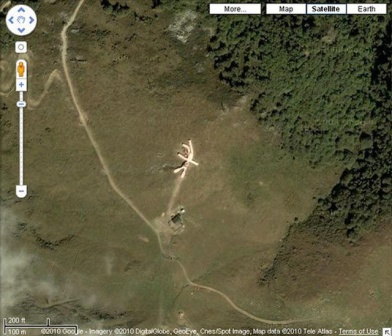What might be the purpose of the X-shaped structure in the clearing? The X-shaped structure in the clearing could serve several potential purposes. Given its large size and distinctive white, metallic construction, it may function as an emergency landing pad for helicopters or small aircraft, particularly designed for areas with limited access by road. This type of structure could also act as a signal marker, guiding aircraft to a specific location for medical evacuations, supply drops, or military operations. Another possibility is that it could be an art installation or part of a scientific or environmental project, used for satellite observation, land survey markers, or even experimental purposes. 